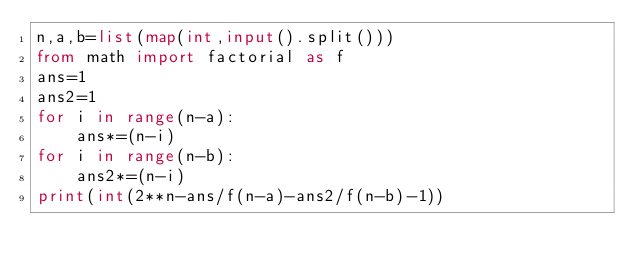<code> <loc_0><loc_0><loc_500><loc_500><_Python_>n,a,b=list(map(int,input().split()))
from math import factorial as f
ans=1
ans2=1
for i in range(n-a):
    ans*=(n-i)
for i in range(n-b):
    ans2*=(n-i)
print(int(2**n-ans/f(n-a)-ans2/f(n-b)-1))</code> 